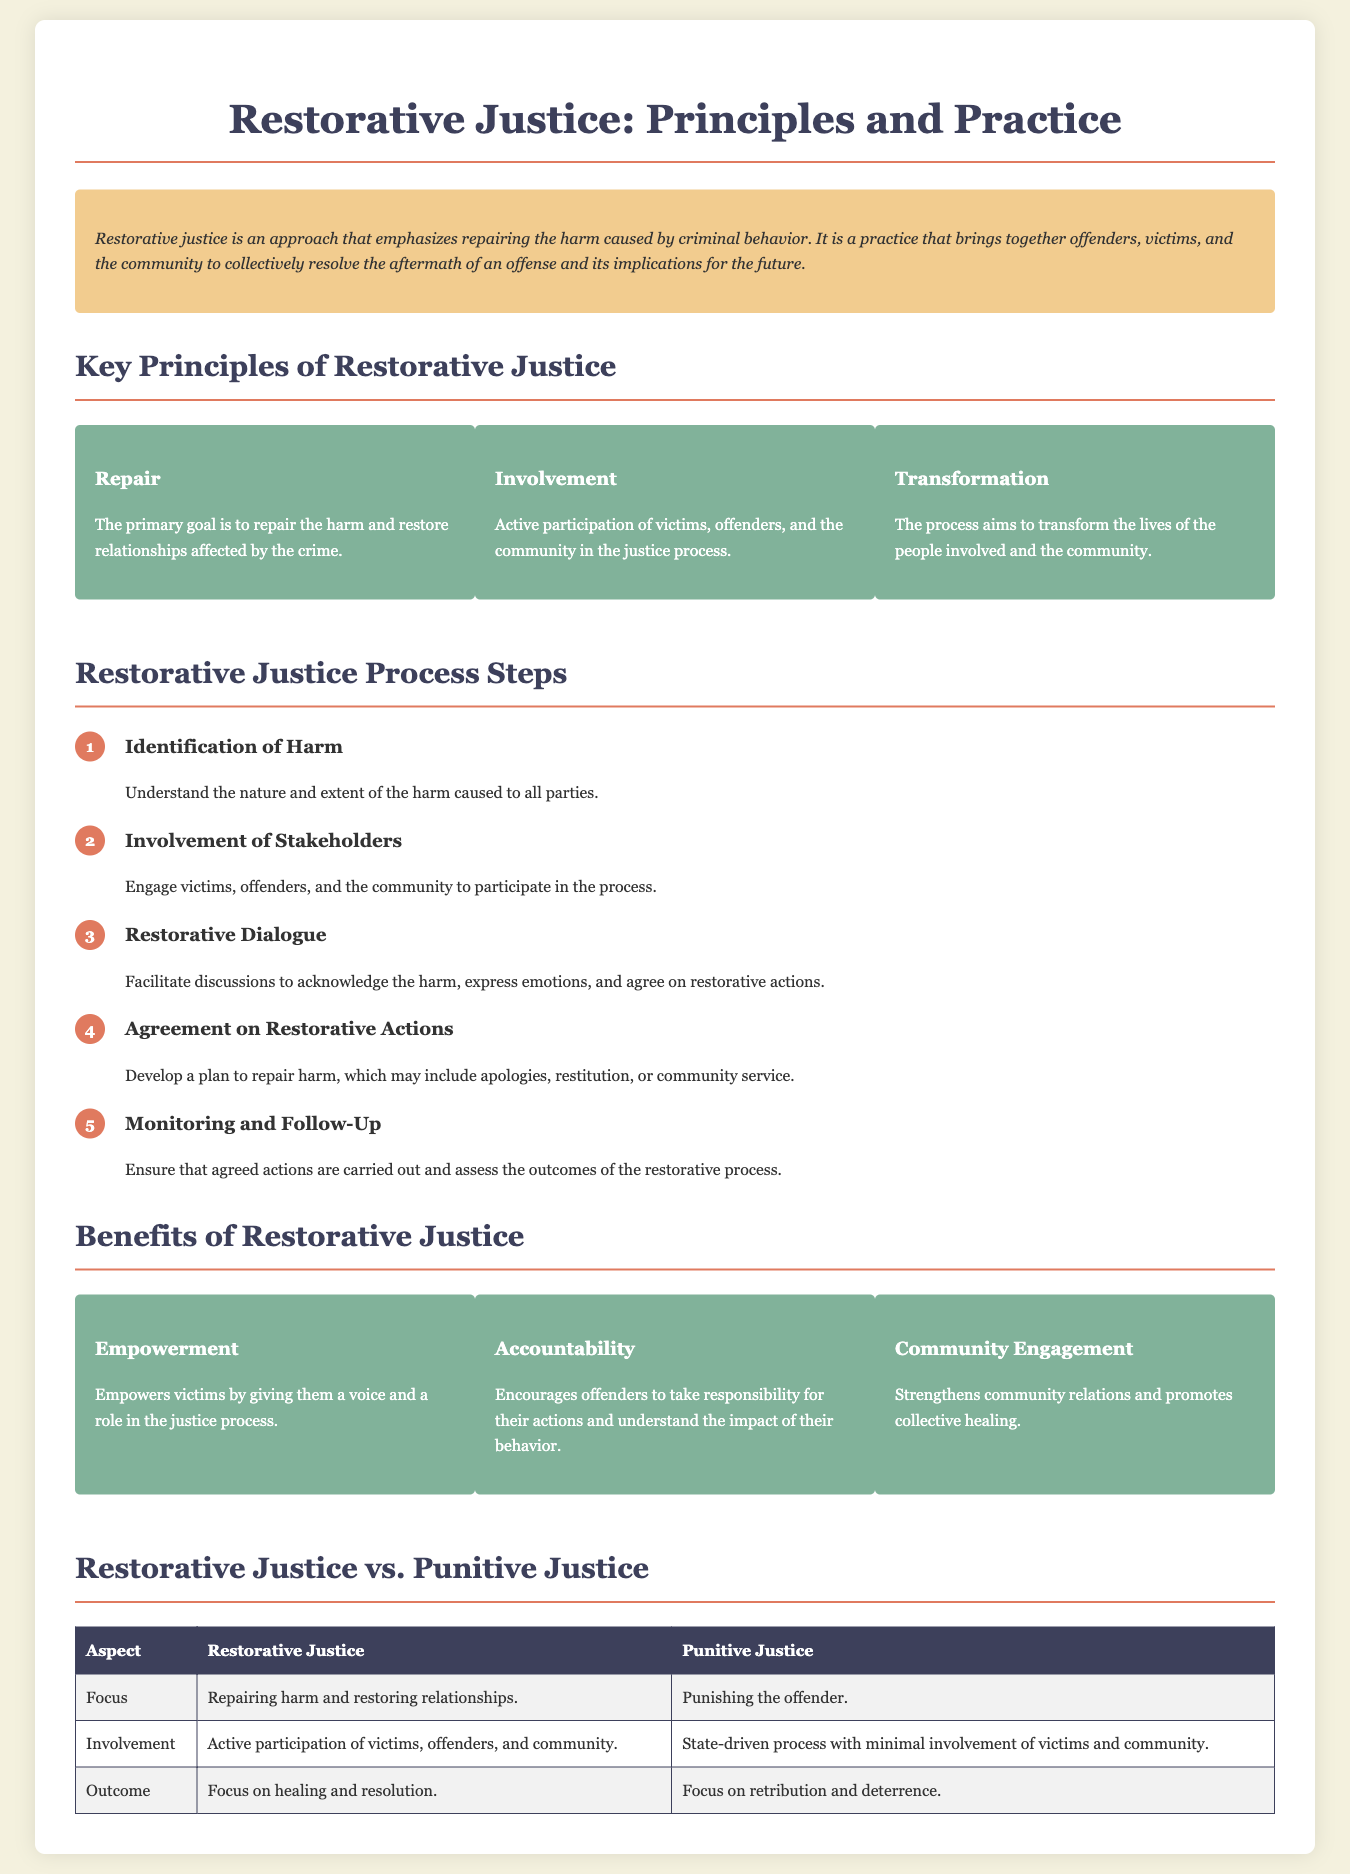what are the three key principles of restorative justice? The document lists three key principles: Repair, Involvement, and Transformation.
Answer: Repair, Involvement, Transformation what is the first step in the restorative justice process? The document indicates that the first step is the identification of harm.
Answer: Identification of Harm what benefit does restorative justice provide to victims? The document states that restorative justice empowers victims by giving them a voice in the justice process.
Answer: Empowerment how does restorative justice view the outcome of its process? According to the document, restorative justice focuses on healing and resolution.
Answer: Healing and resolution what is the main focus of punitive justice? The document describes the main focus of punitive justice as punishing the offender.
Answer: Punishing the offender who participates actively in restorative justice processes? The document specifies that victims, offenders, and the community actively participate.
Answer: Victims, offenders, and community what does the agreement in restorative justice include? The document notes that the agreement may include apologies, restitution, or community service.
Answer: Apologies, restitution, or community service what aspect of community does restorative justice aim to strengthen? The document mentions that restorative justice strengthens community relations and promotes collective healing.
Answer: Community relations and collective healing how is restorative justice different from punitive justice in terms of involvement? The document states that restorative justice involves active participation of victims, offenders, and community, whereas punitive justice is state-driven with minimal involvement.
Answer: Active participation vs. minimal involvement 